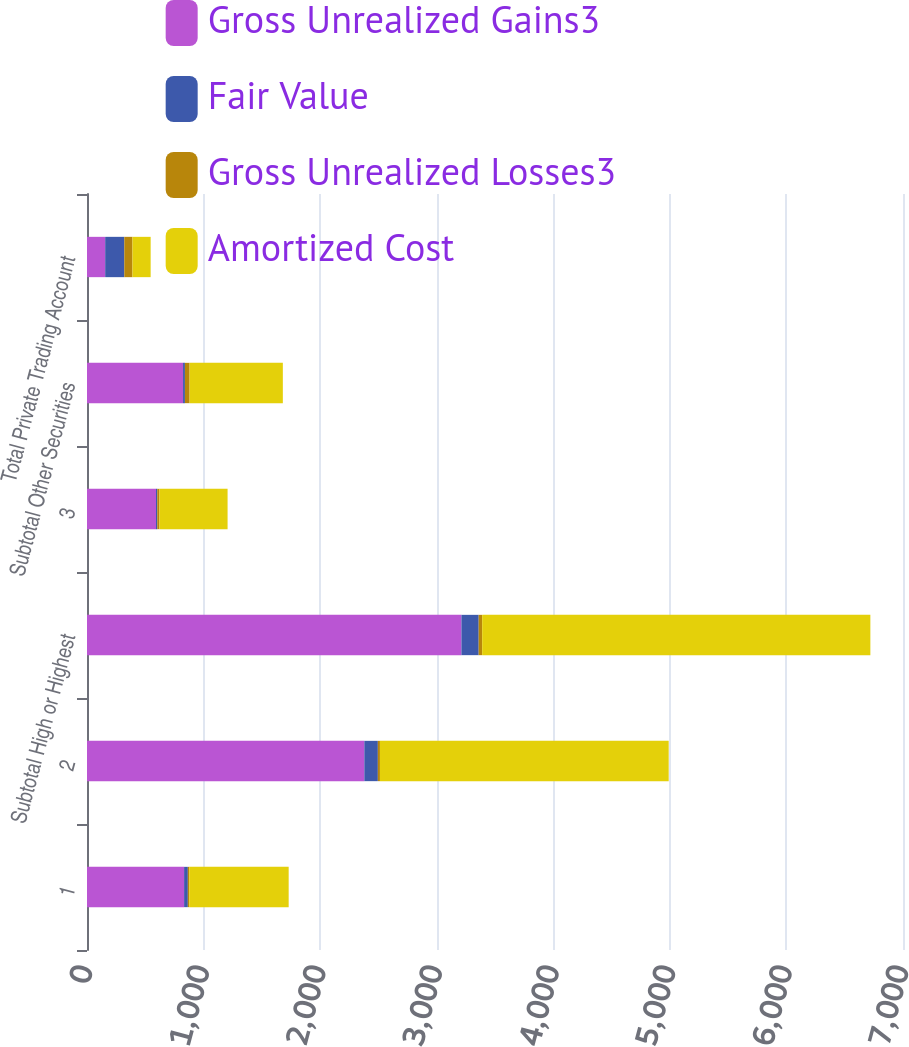Convert chart to OTSL. <chart><loc_0><loc_0><loc_500><loc_500><stacked_bar_chart><ecel><fcel>1<fcel>2<fcel>Subtotal High or Highest<fcel>3<fcel>Subtotal Other Securities<fcel>Total Private Trading Account<nl><fcel>Gross Unrealized Gains3<fcel>833<fcel>2379<fcel>3212<fcel>592<fcel>824<fcel>156<nl><fcel>Fair Value<fcel>32<fcel>116<fcel>148<fcel>11<fcel>16<fcel>164<nl><fcel>Gross Unrealized Losses3<fcel>12<fcel>18<fcel>30<fcel>18<fcel>40<fcel>70<nl><fcel>Amortized Cost<fcel>853<fcel>2477<fcel>3330<fcel>585<fcel>800<fcel>156<nl></chart> 